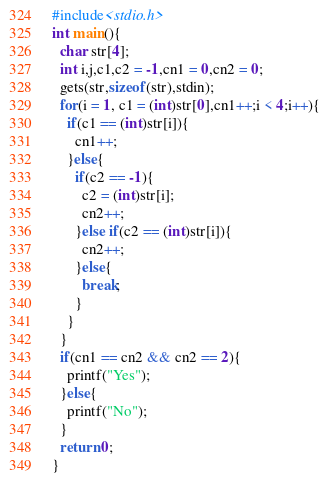<code> <loc_0><loc_0><loc_500><loc_500><_C_>#include<stdio.h>
int main(){
  char str[4];
  int i,j,c1,c2 = -1,cn1 = 0,cn2 = 0;
  gets(str,sizeof(str),stdin);
  for(i = 1, c1 = (int)str[0],cn1++;i < 4;i++){
    if(c1 == (int)str[i]){
      cn1++;
    }else{
      if(c2 == -1){
        c2 = (int)str[i];
        cn2++;
      }else if(c2 == (int)str[i]){
        cn2++;
      }else{
        break;
      }
    }
  }
  if(cn1 == cn2 && cn2 == 2){
    printf("Yes");
  }else{
    printf("No");
  }
  return 0;
}
</code> 